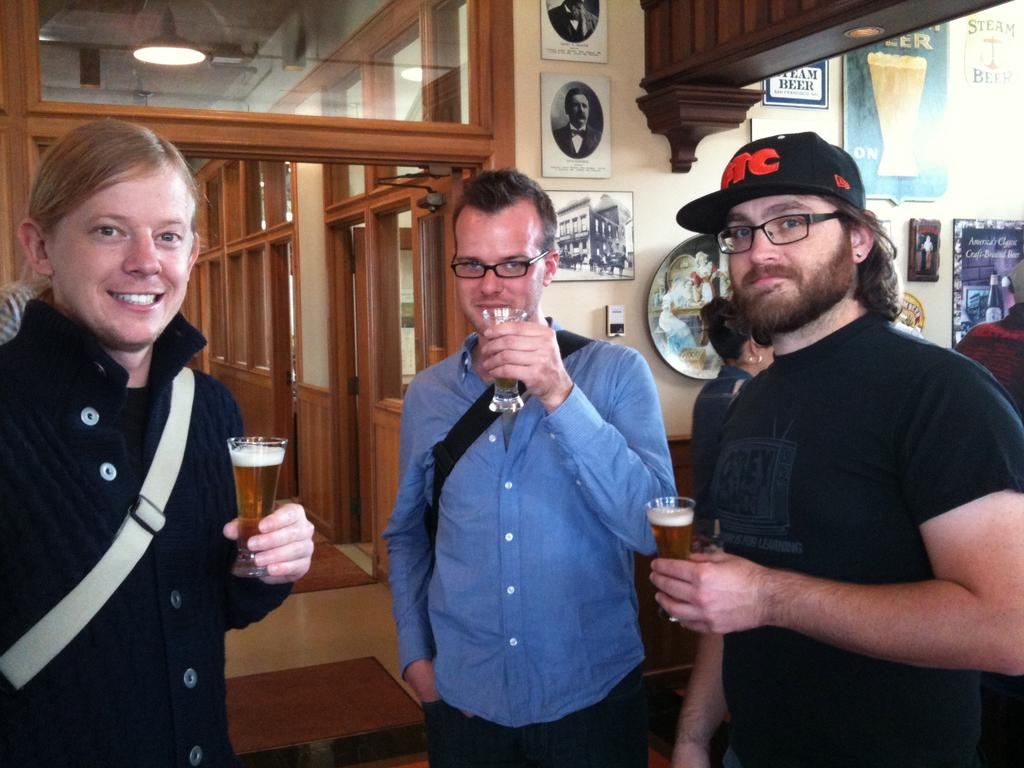How many people are in the image? There are three persons in the image. What are the persons doing in the image? The persons are standing and holding glasses. What can be seen on the wall in the image? There are pictures and posters on the wall. What is the man in the image wearing? One man in the image is wearing a black t-shirt. Can you describe the man's appearance in the image? The man is wearing spectacles. What type of root can be seen growing in the image? There is no root visible in the image. What fact can be determined about the room in the image? The provided facts do not give any information about the room, so no fact can be determined about the room in the image. 